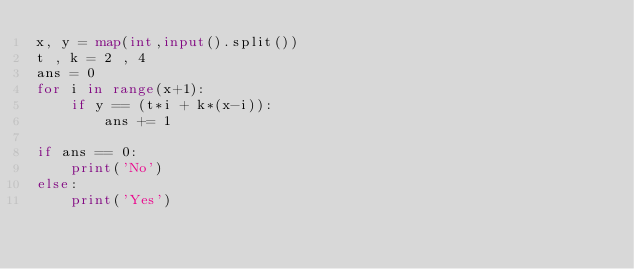Convert code to text. <code><loc_0><loc_0><loc_500><loc_500><_Python_>x, y = map(int,input().split())
t , k = 2 , 4
ans = 0
for i in range(x+1):
    if y == (t*i + k*(x-i)):
        ans += 1

if ans == 0:
    print('No')
else:
    print('Yes')</code> 